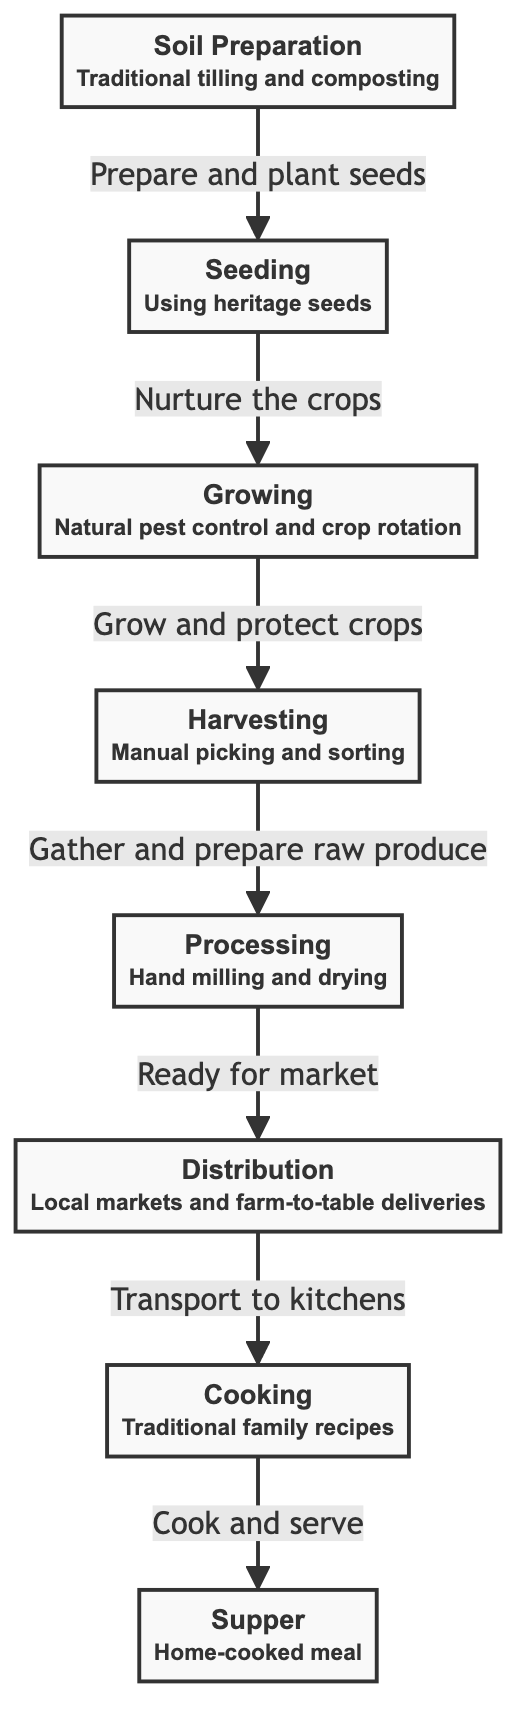What is the first step in the food chain? The first step in the food chain is soil preparation, which initiates the entire process. It involves traditional tilling and composting to prepare the land for planting.
Answer: Soil Preparation How many nodes are there in total? By counting each distinct step in the process from soil to supper, there are eight nodes: Soil Preparation, Seeding, Growing, Harvesting, Processing, Distribution, Cooking, and Supper.
Answer: 8 What is the last process before the food reaches the supper? The last process before reaching the supper is cooking, where traditional family recipes are used to prepare the food for serving.
Answer: Cooking Which step involves natural pest control? The step that involves natural pest control is growing, where crops are nurtured while protecting them from pests through organic methods.
Answer: Growing How are crops harvested according to the diagram? Crops are harvested through manual picking and sorting, highlighting the traditional approach of gathering produce without machinery.
Answer: Manual picking and sorting What type of seeds are used in the seeding process? The seeding process uses heritage seeds, which are traditional seeds known for their unique characteristics and history.
Answer: Heritage seeds What does processing involve? Processing involves hand milling and drying, emphasizing labor-intensive methods to prepare the food for the market.
Answer: Hand milling and drying Where does the food go after distribution? After distribution, the food is transported to kitchens, where it is ready to be cooked using traditional family recipes before being served.
Answer: Kitchens What connects growing and harvesting steps? The connection between growing and harvesting is indicated by the nurturing and protection of crops, which is essential for ensuring a successful harvest.
Answer: Nurture the crops 